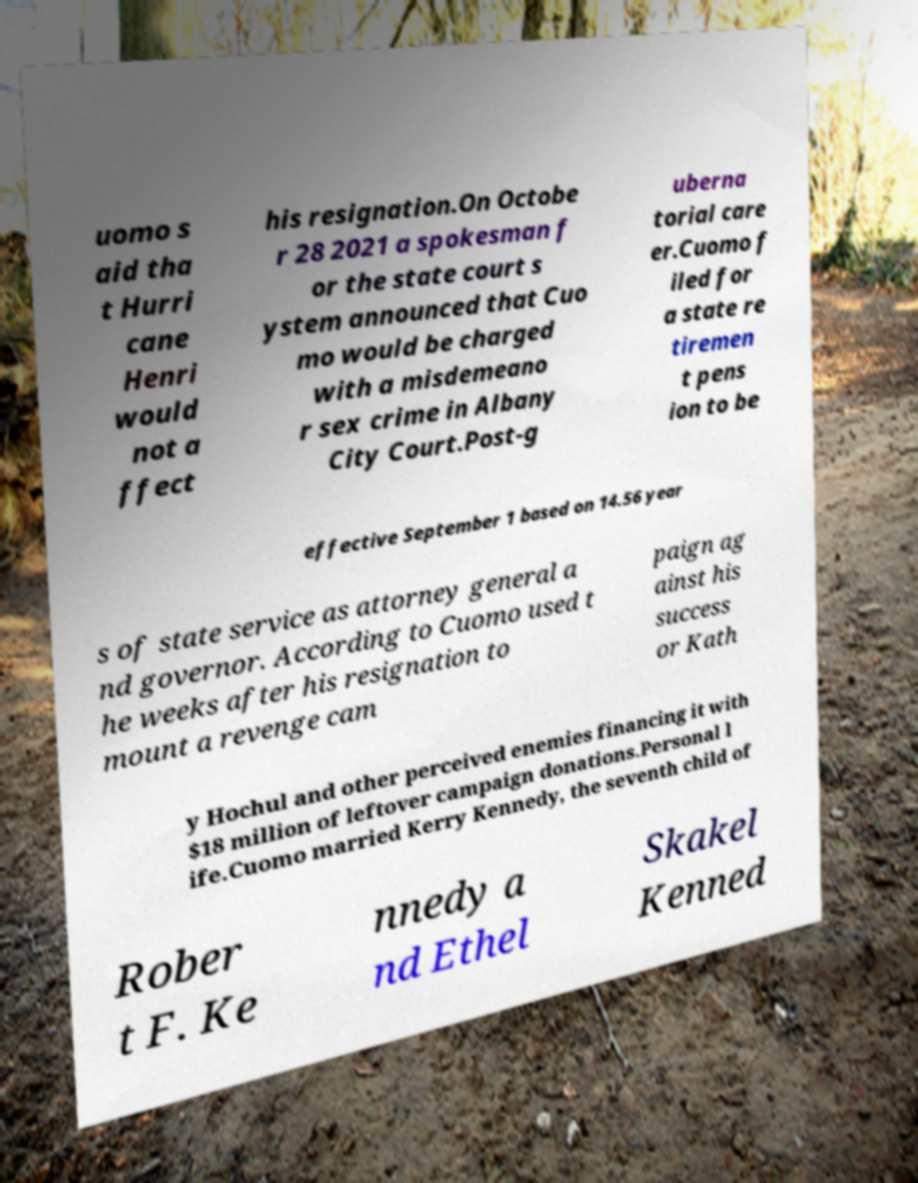There's text embedded in this image that I need extracted. Can you transcribe it verbatim? uomo s aid tha t Hurri cane Henri would not a ffect his resignation.On Octobe r 28 2021 a spokesman f or the state court s ystem announced that Cuo mo would be charged with a misdemeano r sex crime in Albany City Court.Post-g uberna torial care er.Cuomo f iled for a state re tiremen t pens ion to be effective September 1 based on 14.56 year s of state service as attorney general a nd governor. According to Cuomo used t he weeks after his resignation to mount a revenge cam paign ag ainst his success or Kath y Hochul and other perceived enemies financing it with $18 million of leftover campaign donations.Personal l ife.Cuomo married Kerry Kennedy, the seventh child of Rober t F. Ke nnedy a nd Ethel Skakel Kenned 